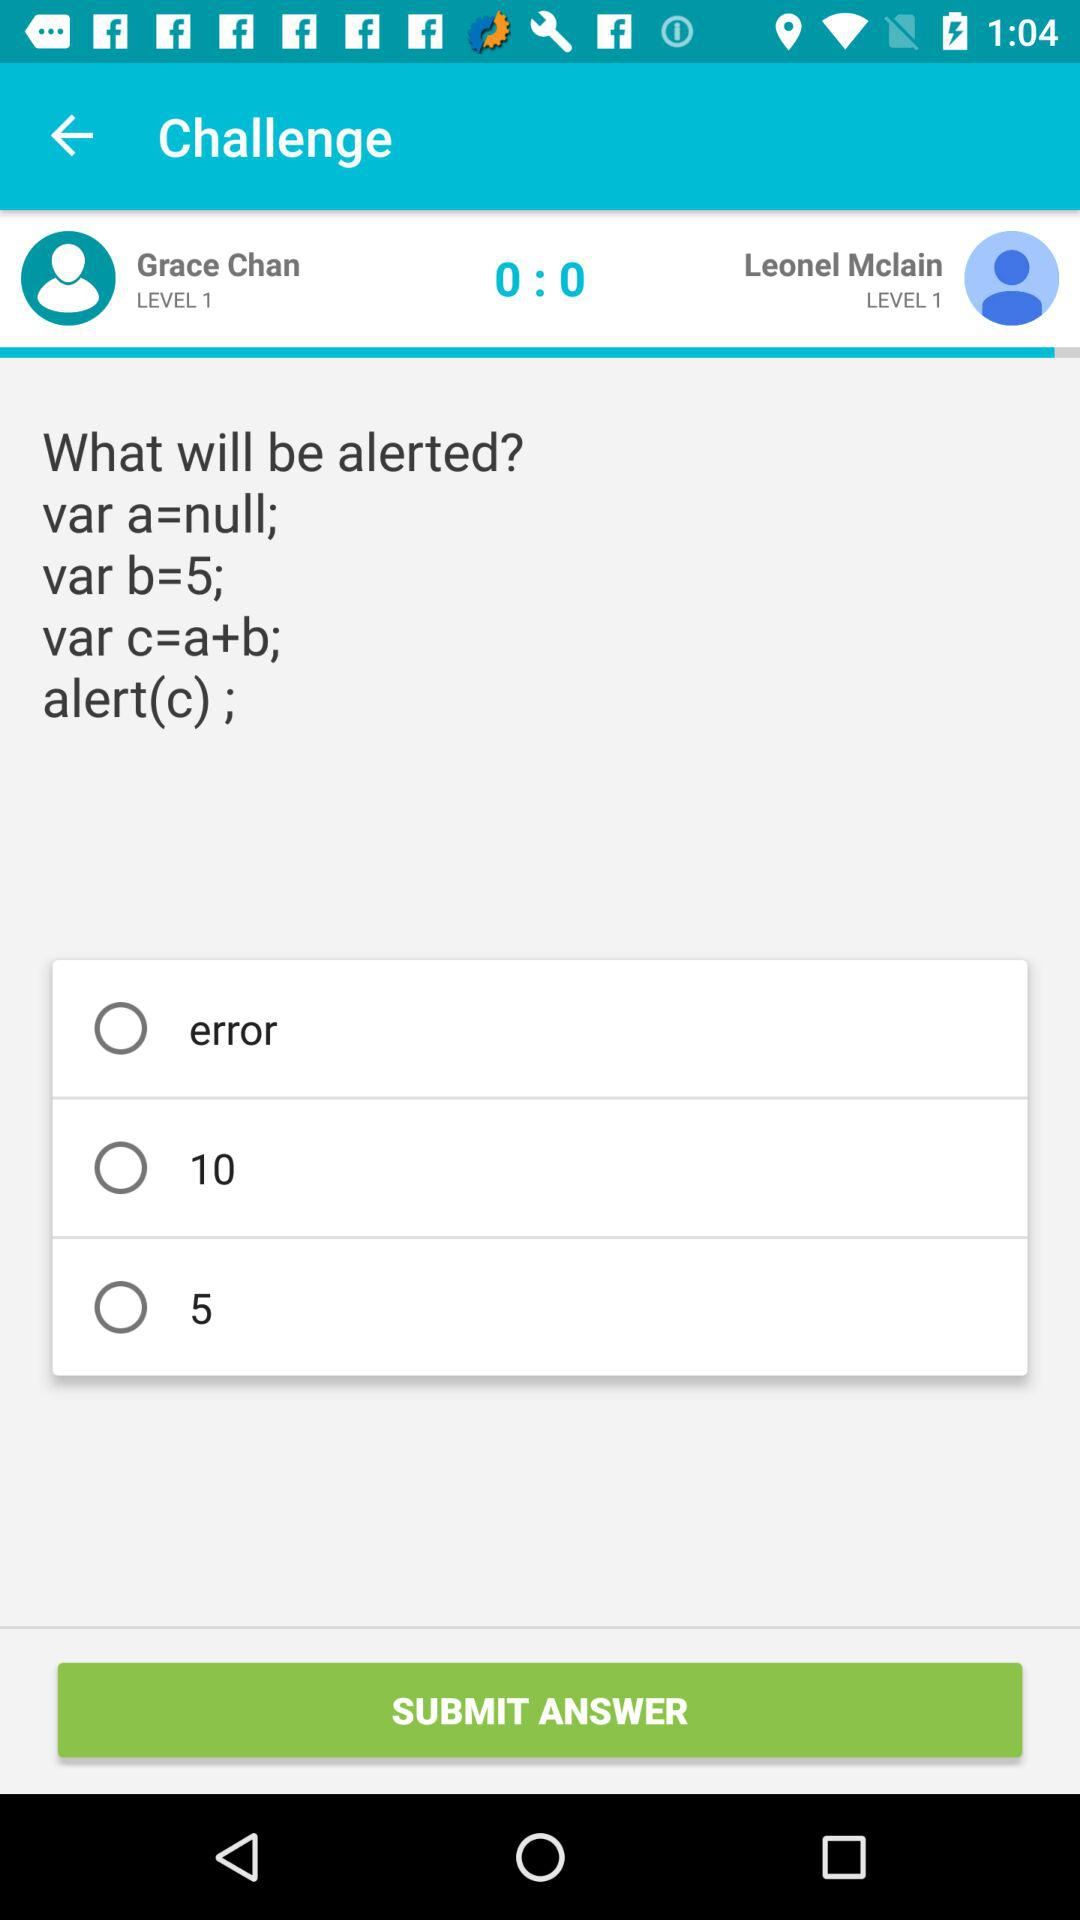What is the score? The score is 0:0. 